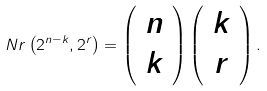<formula> <loc_0><loc_0><loc_500><loc_500>N r \left ( 2 ^ { n - k } , 2 ^ { r } \right ) = \left ( \begin{array} { c } n \\ k \end{array} \right ) \left ( \begin{array} { c } k \\ r \end{array} \right ) .</formula> 